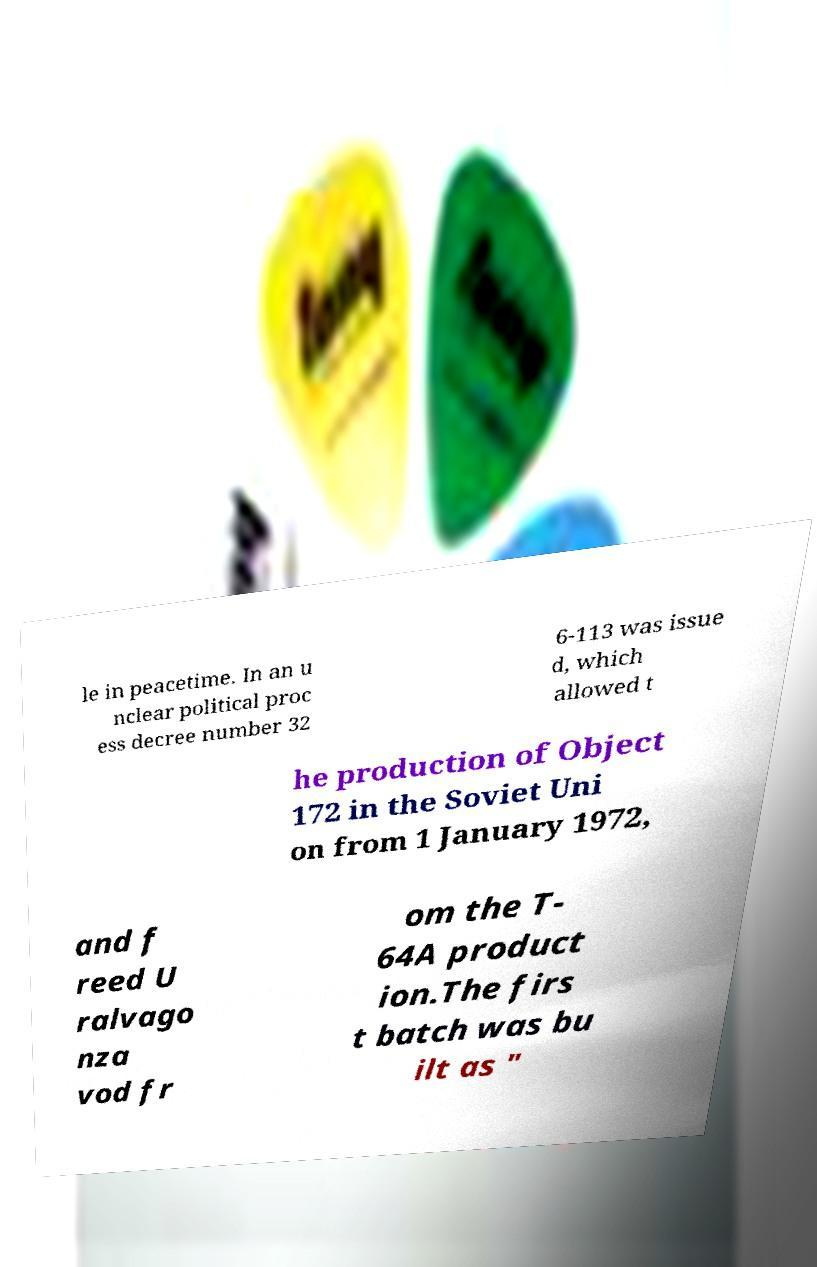Can you read and provide the text displayed in the image?This photo seems to have some interesting text. Can you extract and type it out for me? le in peacetime. In an u nclear political proc ess decree number 32 6-113 was issue d, which allowed t he production of Object 172 in the Soviet Uni on from 1 January 1972, and f reed U ralvago nza vod fr om the T- 64A product ion.The firs t batch was bu ilt as " 